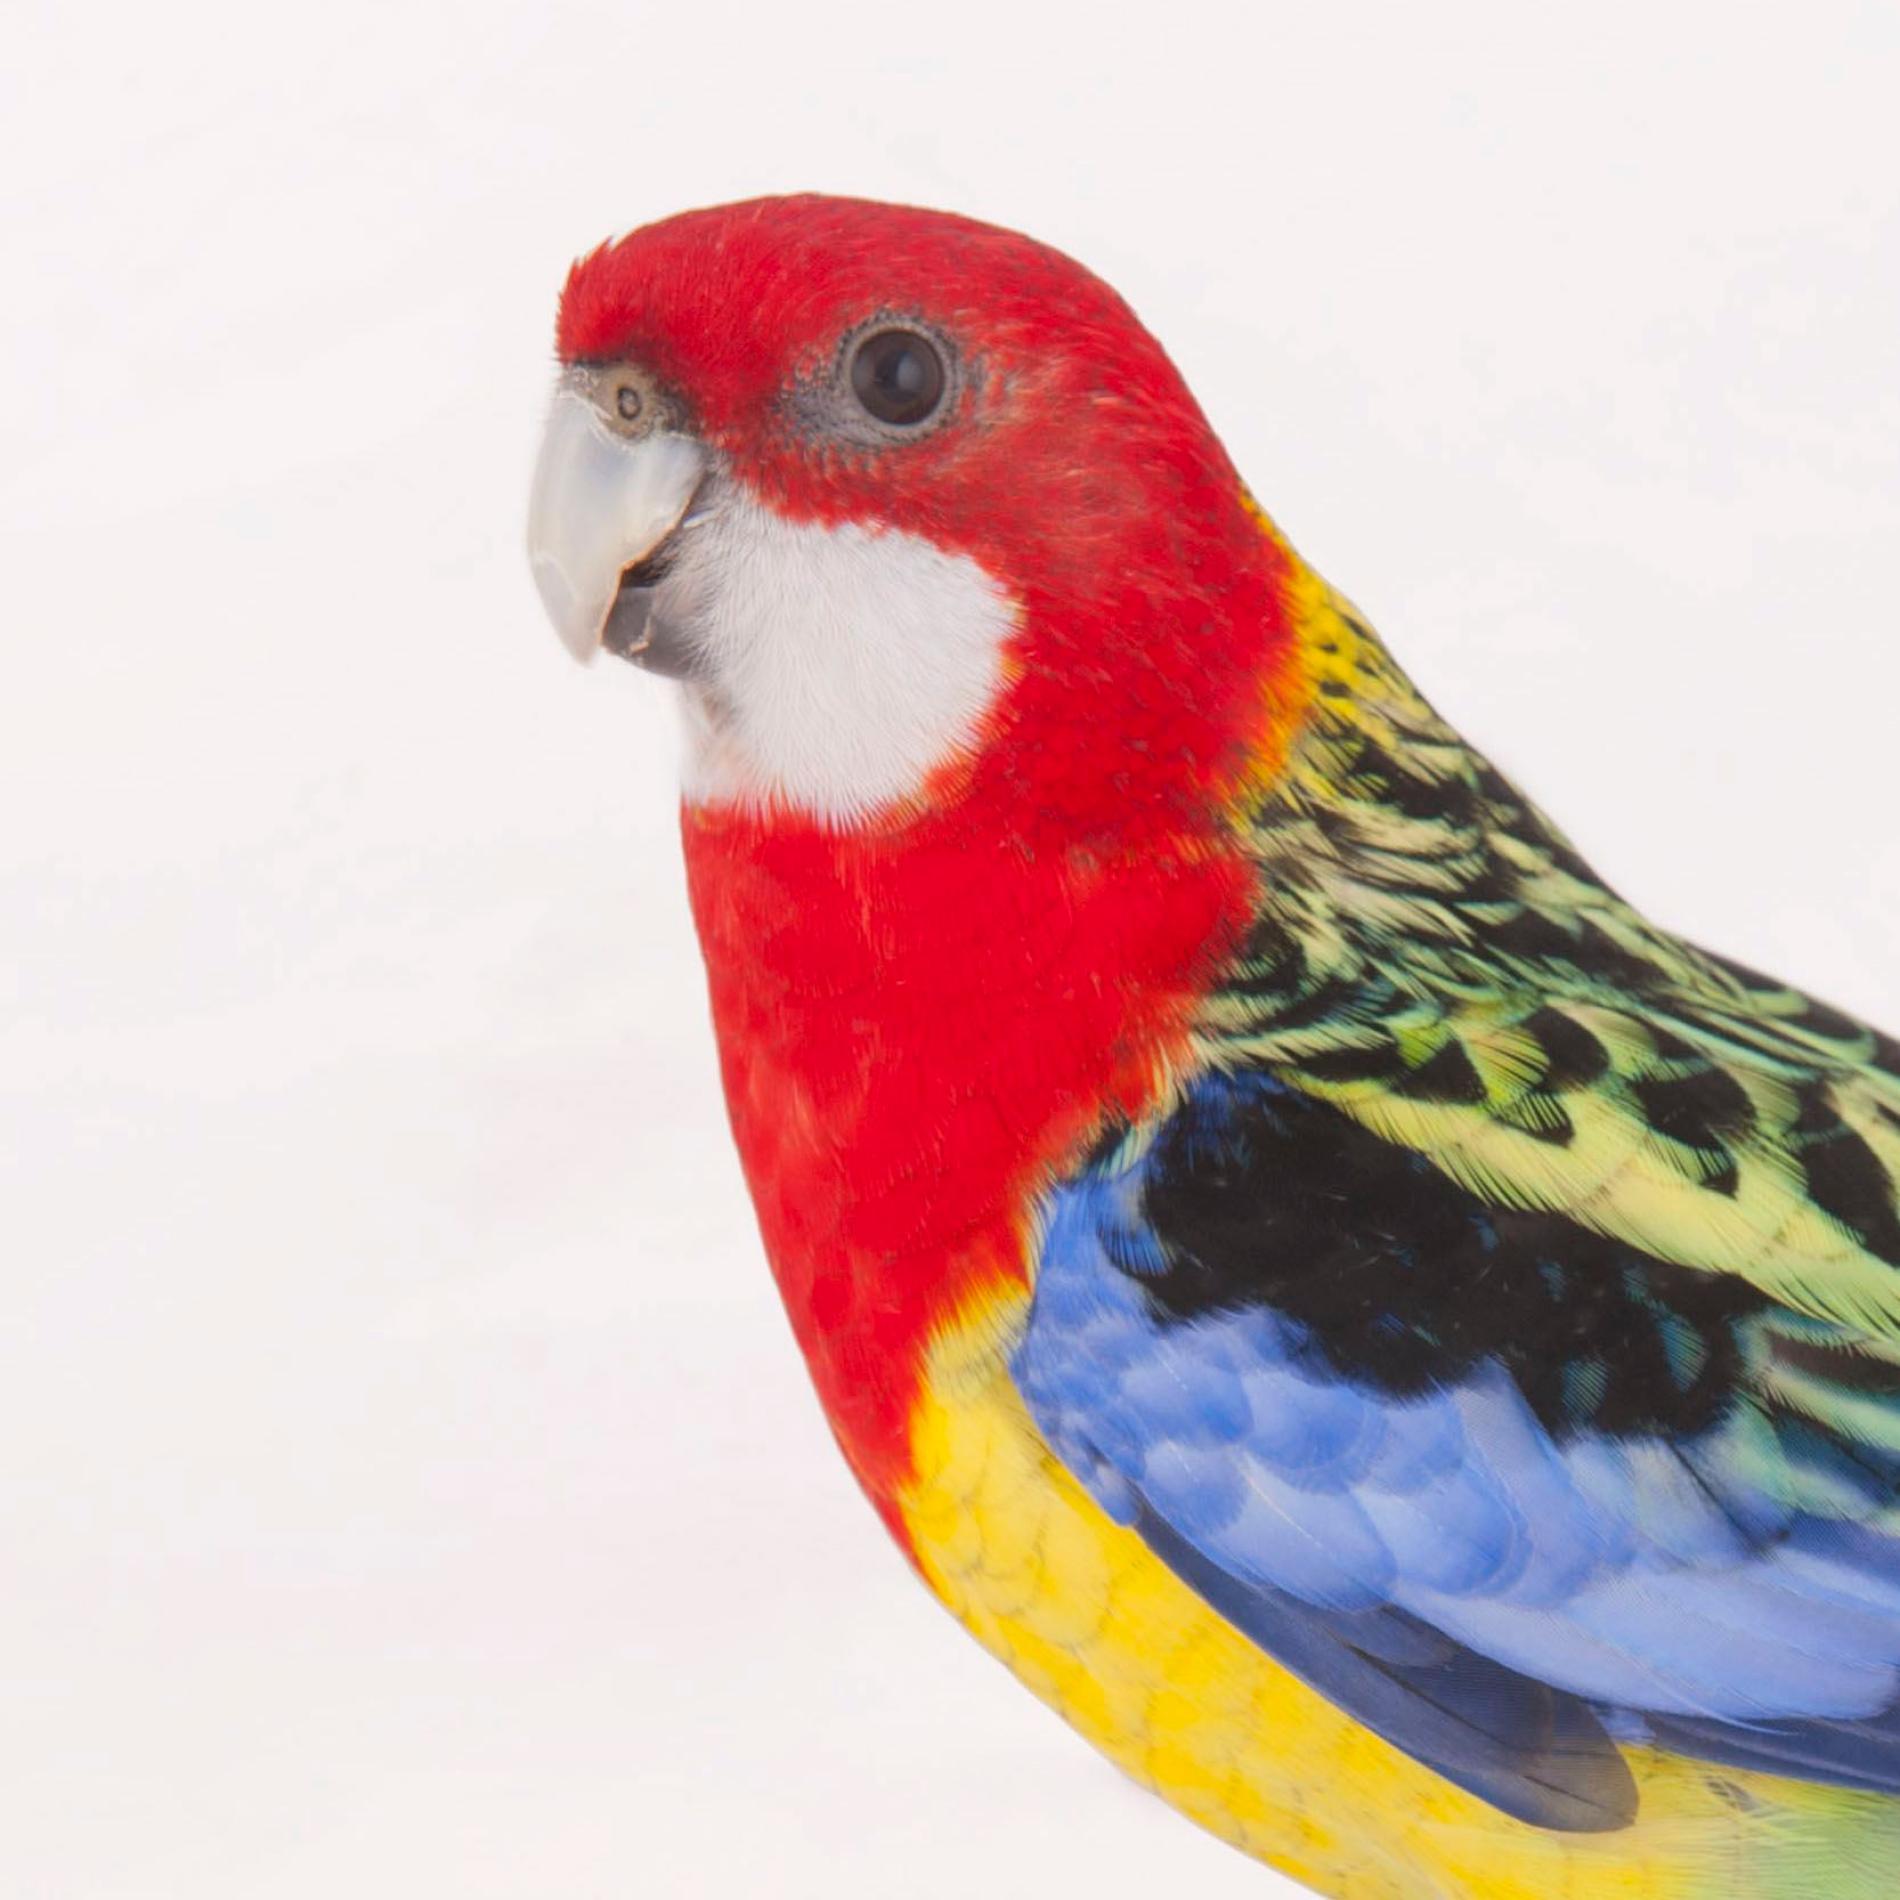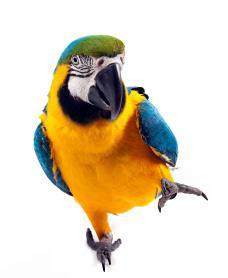The first image is the image on the left, the second image is the image on the right. Examine the images to the left and right. Is the description "There is no more than one bird in each image." accurate? Answer yes or no. Yes. The first image is the image on the left, the second image is the image on the right. Examine the images to the left and right. Is the description "There are two parrots." accurate? Answer yes or no. Yes. 